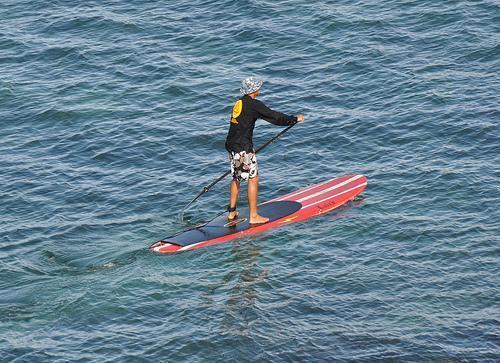How many men are there?
Give a very brief answer. 1. 